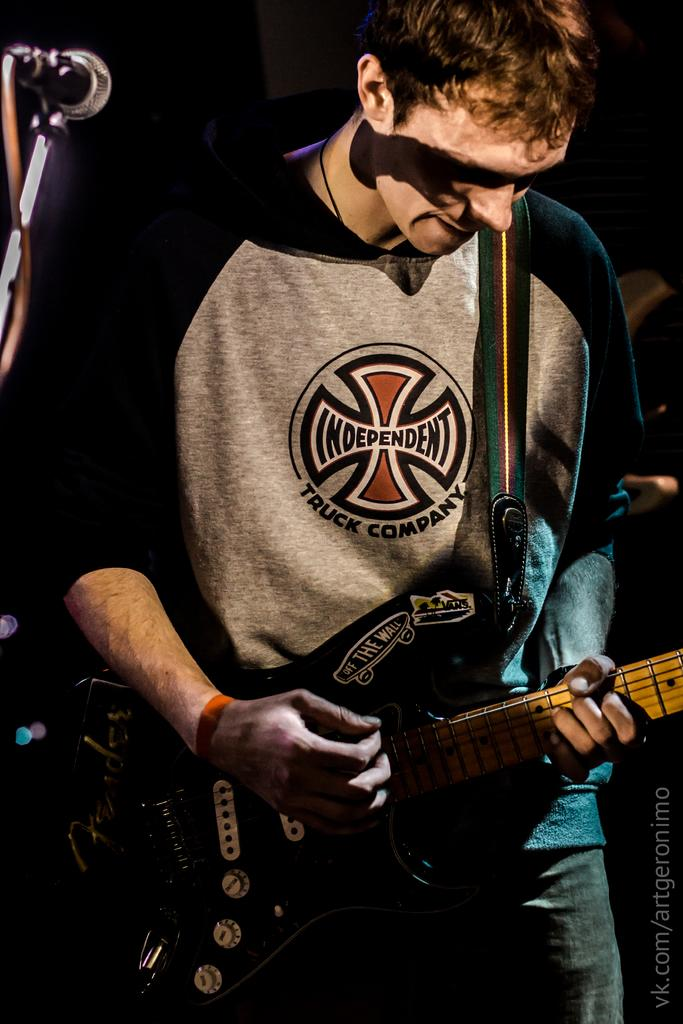What is the main subject of the image? There is a person standing in the center of the image. What is the person doing in the image? The person is playing a guitar. What object is located on the left side of the image? There is a microphone on the left side of the image. How many cakes are visible in the image? There are no cakes present in the image. What book is the person reading while playing the guitar? The person is not reading a book in the image; they are playing the guitar. 